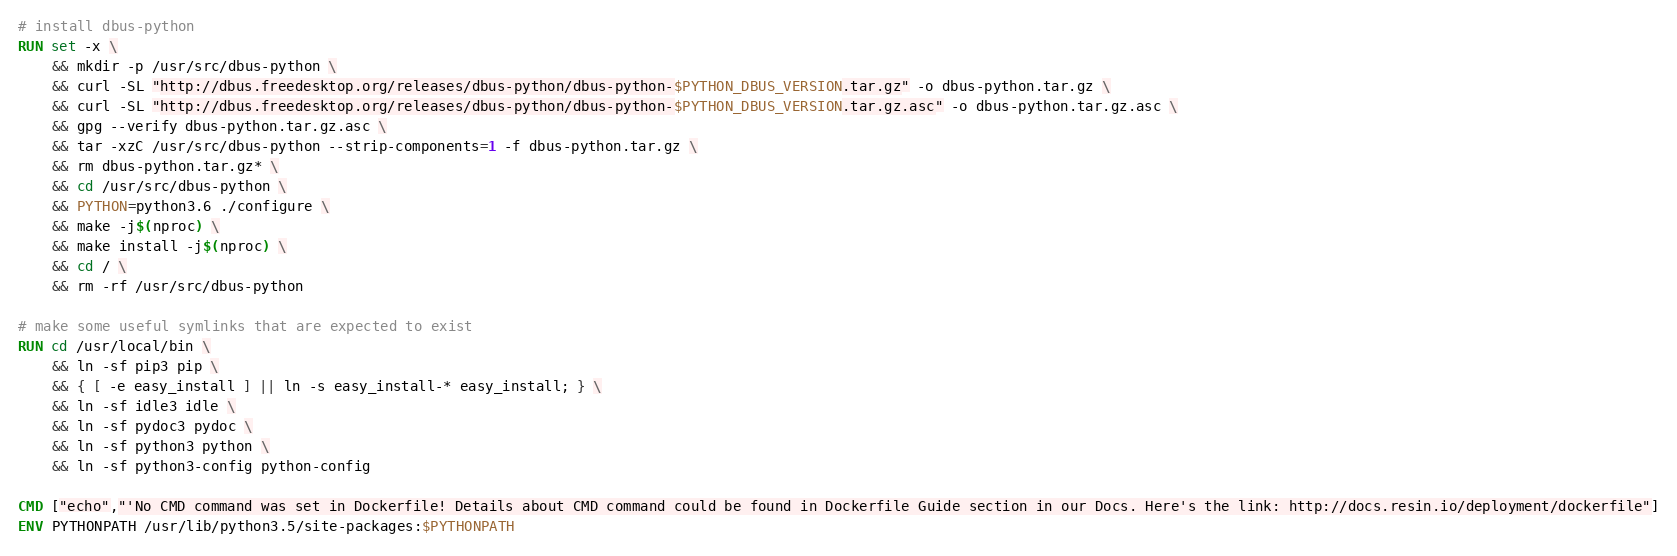<code> <loc_0><loc_0><loc_500><loc_500><_Dockerfile_># install dbus-python
RUN set -x \
	&& mkdir -p /usr/src/dbus-python \
	&& curl -SL "http://dbus.freedesktop.org/releases/dbus-python/dbus-python-$PYTHON_DBUS_VERSION.tar.gz" -o dbus-python.tar.gz \
	&& curl -SL "http://dbus.freedesktop.org/releases/dbus-python/dbus-python-$PYTHON_DBUS_VERSION.tar.gz.asc" -o dbus-python.tar.gz.asc \
	&& gpg --verify dbus-python.tar.gz.asc \
	&& tar -xzC /usr/src/dbus-python --strip-components=1 -f dbus-python.tar.gz \
	&& rm dbus-python.tar.gz* \
	&& cd /usr/src/dbus-python \
	&& PYTHON=python3.6 ./configure \
	&& make -j$(nproc) \
	&& make install -j$(nproc) \
	&& cd / \
	&& rm -rf /usr/src/dbus-python

# make some useful symlinks that are expected to exist
RUN cd /usr/local/bin \
	&& ln -sf pip3 pip \
	&& { [ -e easy_install ] || ln -s easy_install-* easy_install; } \
	&& ln -sf idle3 idle \
	&& ln -sf pydoc3 pydoc \
	&& ln -sf python3 python \
	&& ln -sf python3-config python-config

CMD ["echo","'No CMD command was set in Dockerfile! Details about CMD command could be found in Dockerfile Guide section in our Docs. Here's the link: http://docs.resin.io/deployment/dockerfile"]
ENV PYTHONPATH /usr/lib/python3.5/site-packages:$PYTHONPATH
</code> 